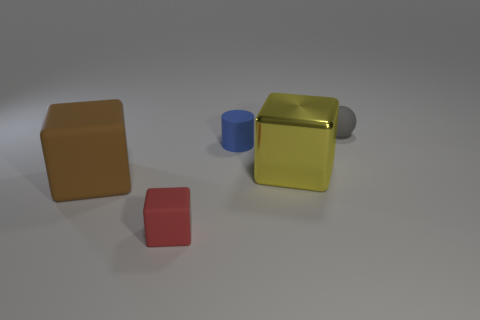Subtract all big blocks. How many blocks are left? 1 Add 4 big green metallic spheres. How many objects exist? 9 Subtract all brown blocks. How many blocks are left? 2 Subtract 1 cylinders. How many cylinders are left? 0 Subtract all cylinders. How many objects are left? 4 Subtract all brown cylinders. How many yellow blocks are left? 1 Subtract all tiny gray rubber balls. Subtract all red cylinders. How many objects are left? 4 Add 3 large metal objects. How many large metal objects are left? 4 Add 4 big yellow shiny things. How many big yellow shiny things exist? 5 Subtract 0 green cylinders. How many objects are left? 5 